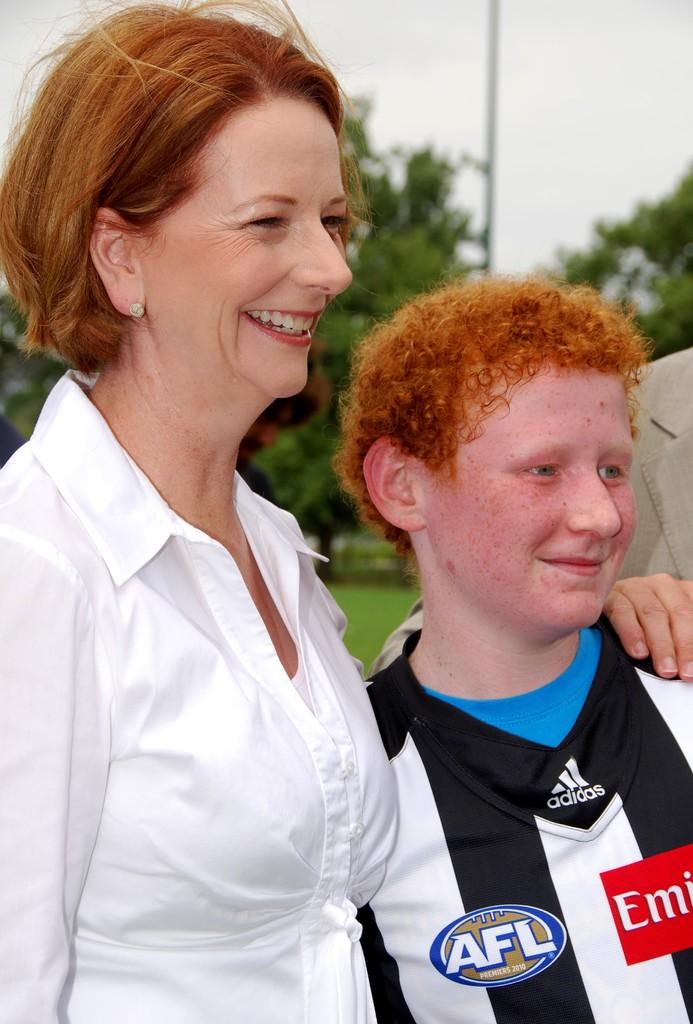What league is he in?
Offer a terse response. Afl. What brand is his jersey?
Your answer should be very brief. Adidas. 